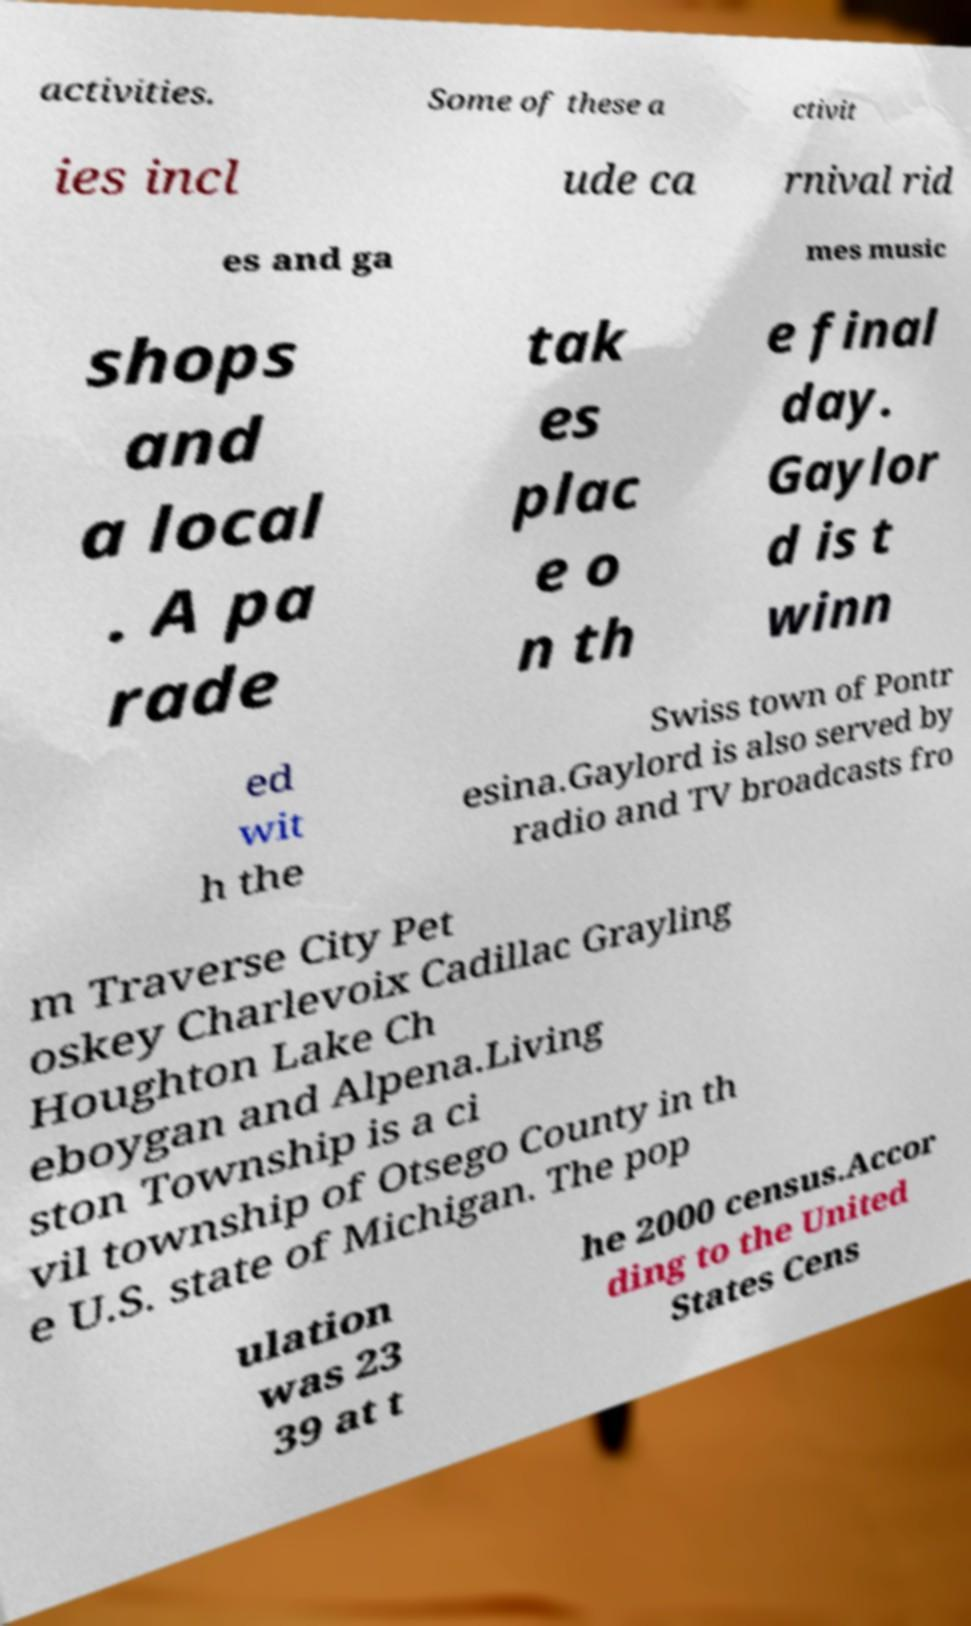Could you extract and type out the text from this image? activities. Some of these a ctivit ies incl ude ca rnival rid es and ga mes music shops and a local . A pa rade tak es plac e o n th e final day. Gaylor d is t winn ed wit h the Swiss town of Pontr esina.Gaylord is also served by radio and TV broadcasts fro m Traverse City Pet oskey Charlevoix Cadillac Grayling Houghton Lake Ch eboygan and Alpena.Living ston Township is a ci vil township of Otsego County in th e U.S. state of Michigan. The pop ulation was 23 39 at t he 2000 census.Accor ding to the United States Cens 